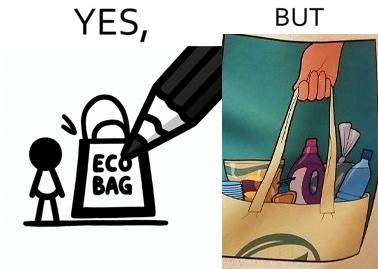What makes this image funny or satirical? The image is ironical because in the left image it is written eco bag but in the right image we are keeping items of plastic which is not eco-friendly. 